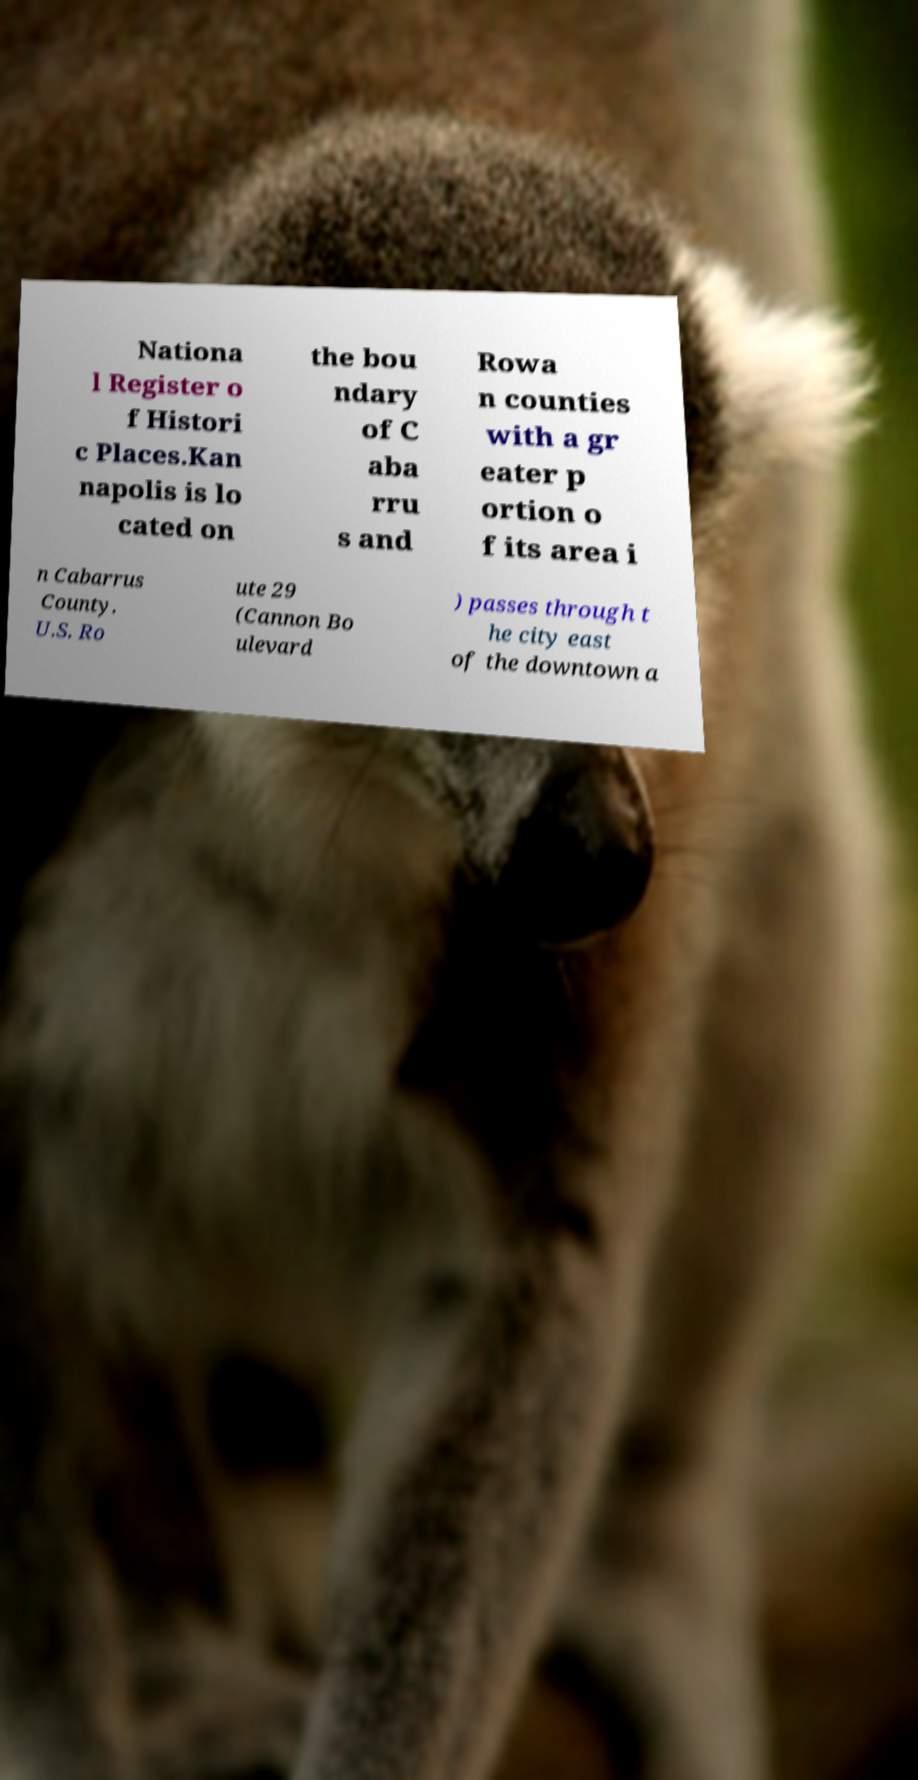Can you accurately transcribe the text from the provided image for me? Nationa l Register o f Histori c Places.Kan napolis is lo cated on the bou ndary of C aba rru s and Rowa n counties with a gr eater p ortion o f its area i n Cabarrus County. U.S. Ro ute 29 (Cannon Bo ulevard ) passes through t he city east of the downtown a 